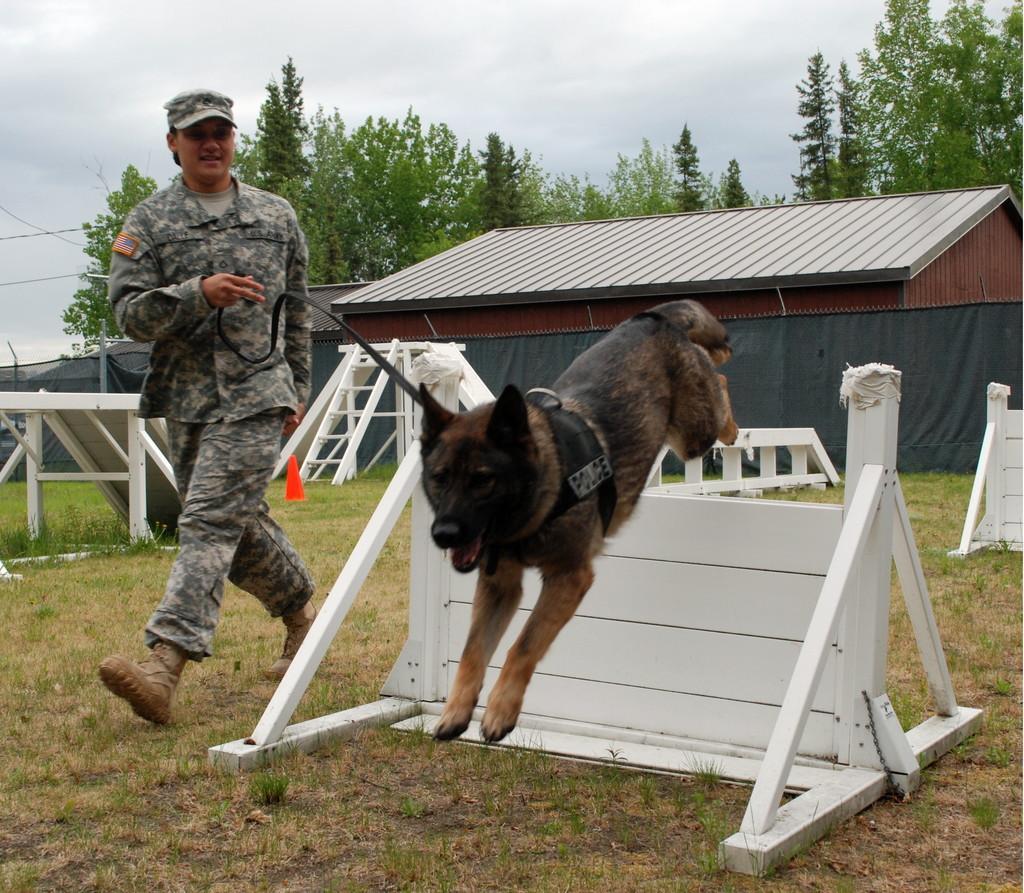Please provide a concise description of this image. This picture is taken from the outside of the city. In this image, on the left side, we can also see a person walking and holding a collar rope of a dog which is in the middle. The dog is also jumping from small wall. On the right side, we can see a small wall. On the left side, we can see a table. In the background, we can see a ladder, table, wall, house, trees. At the top, we can see a sky which is cloudy, at the bottom, we can see a grass. 